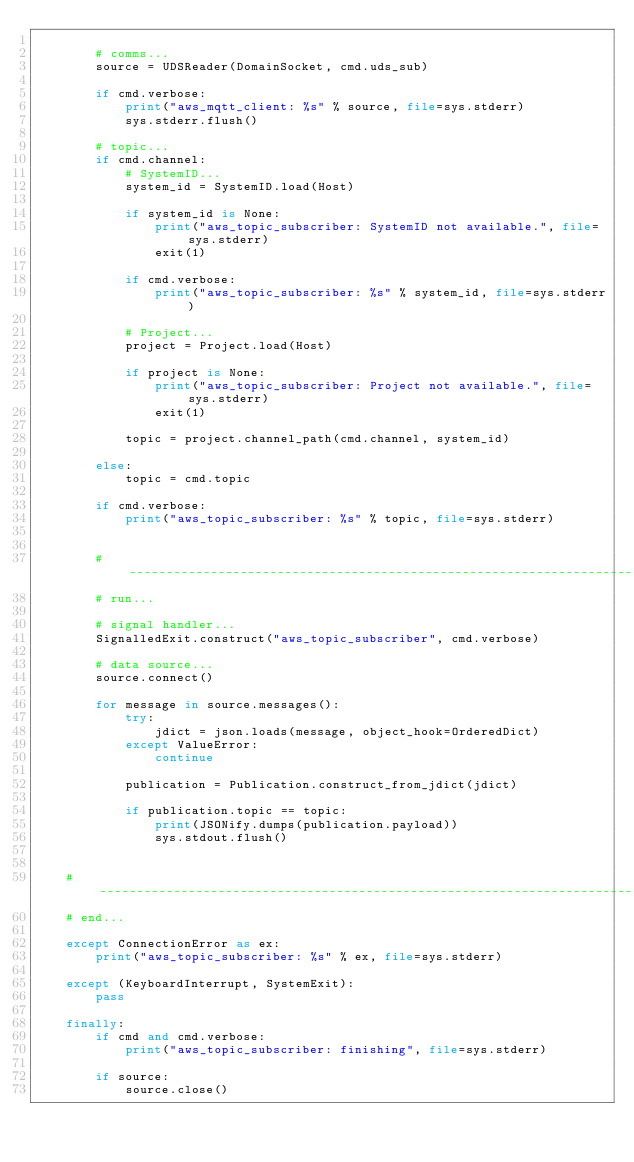<code> <loc_0><loc_0><loc_500><loc_500><_Python_>
        # comms...
        source = UDSReader(DomainSocket, cmd.uds_sub)

        if cmd.verbose:
            print("aws_mqtt_client: %s" % source, file=sys.stderr)
            sys.stderr.flush()

        # topic...
        if cmd.channel:
            # SystemID...
            system_id = SystemID.load(Host)

            if system_id is None:
                print("aws_topic_subscriber: SystemID not available.", file=sys.stderr)
                exit(1)

            if cmd.verbose:
                print("aws_topic_subscriber: %s" % system_id, file=sys.stderr)

            # Project...
            project = Project.load(Host)

            if project is None:
                print("aws_topic_subscriber: Project not available.", file=sys.stderr)
                exit(1)

            topic = project.channel_path(cmd.channel, system_id)

        else:
            topic = cmd.topic

        if cmd.verbose:
            print("aws_topic_subscriber: %s" % topic, file=sys.stderr)


        # ------------------------------------------------------------------------------------------------------------
        # run...

        # signal handler...
        SignalledExit.construct("aws_topic_subscriber", cmd.verbose)

        # data source...
        source.connect()

        for message in source.messages():
            try:
                jdict = json.loads(message, object_hook=OrderedDict)
            except ValueError:
                continue

            publication = Publication.construct_from_jdict(jdict)

            if publication.topic == topic:
                print(JSONify.dumps(publication.payload))
                sys.stdout.flush()


    # ----------------------------------------------------------------------------------------------------------------
    # end...

    except ConnectionError as ex:
        print("aws_topic_subscriber: %s" % ex, file=sys.stderr)

    except (KeyboardInterrupt, SystemExit):
        pass

    finally:
        if cmd and cmd.verbose:
            print("aws_topic_subscriber: finishing", file=sys.stderr)

        if source:
            source.close()
</code> 